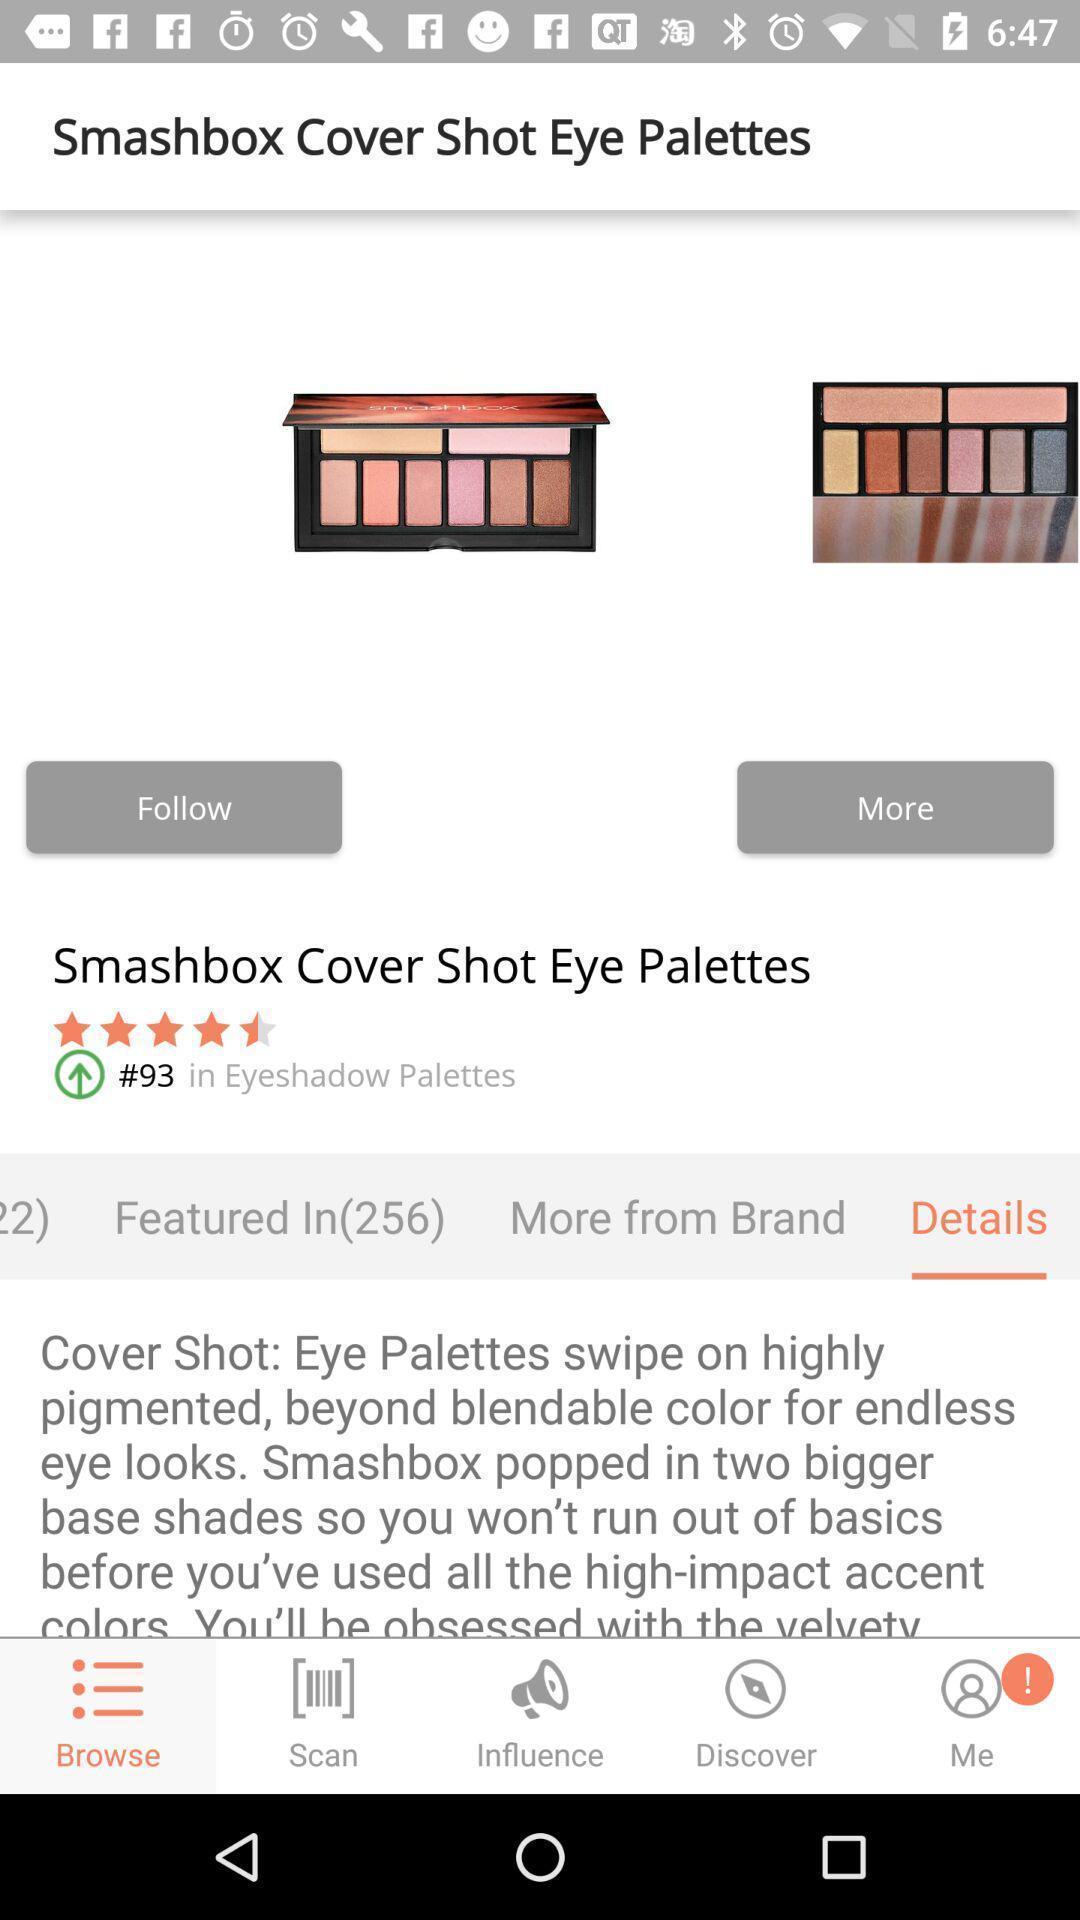Please provide a description for this image. Screen shows product details in a shopping app. 